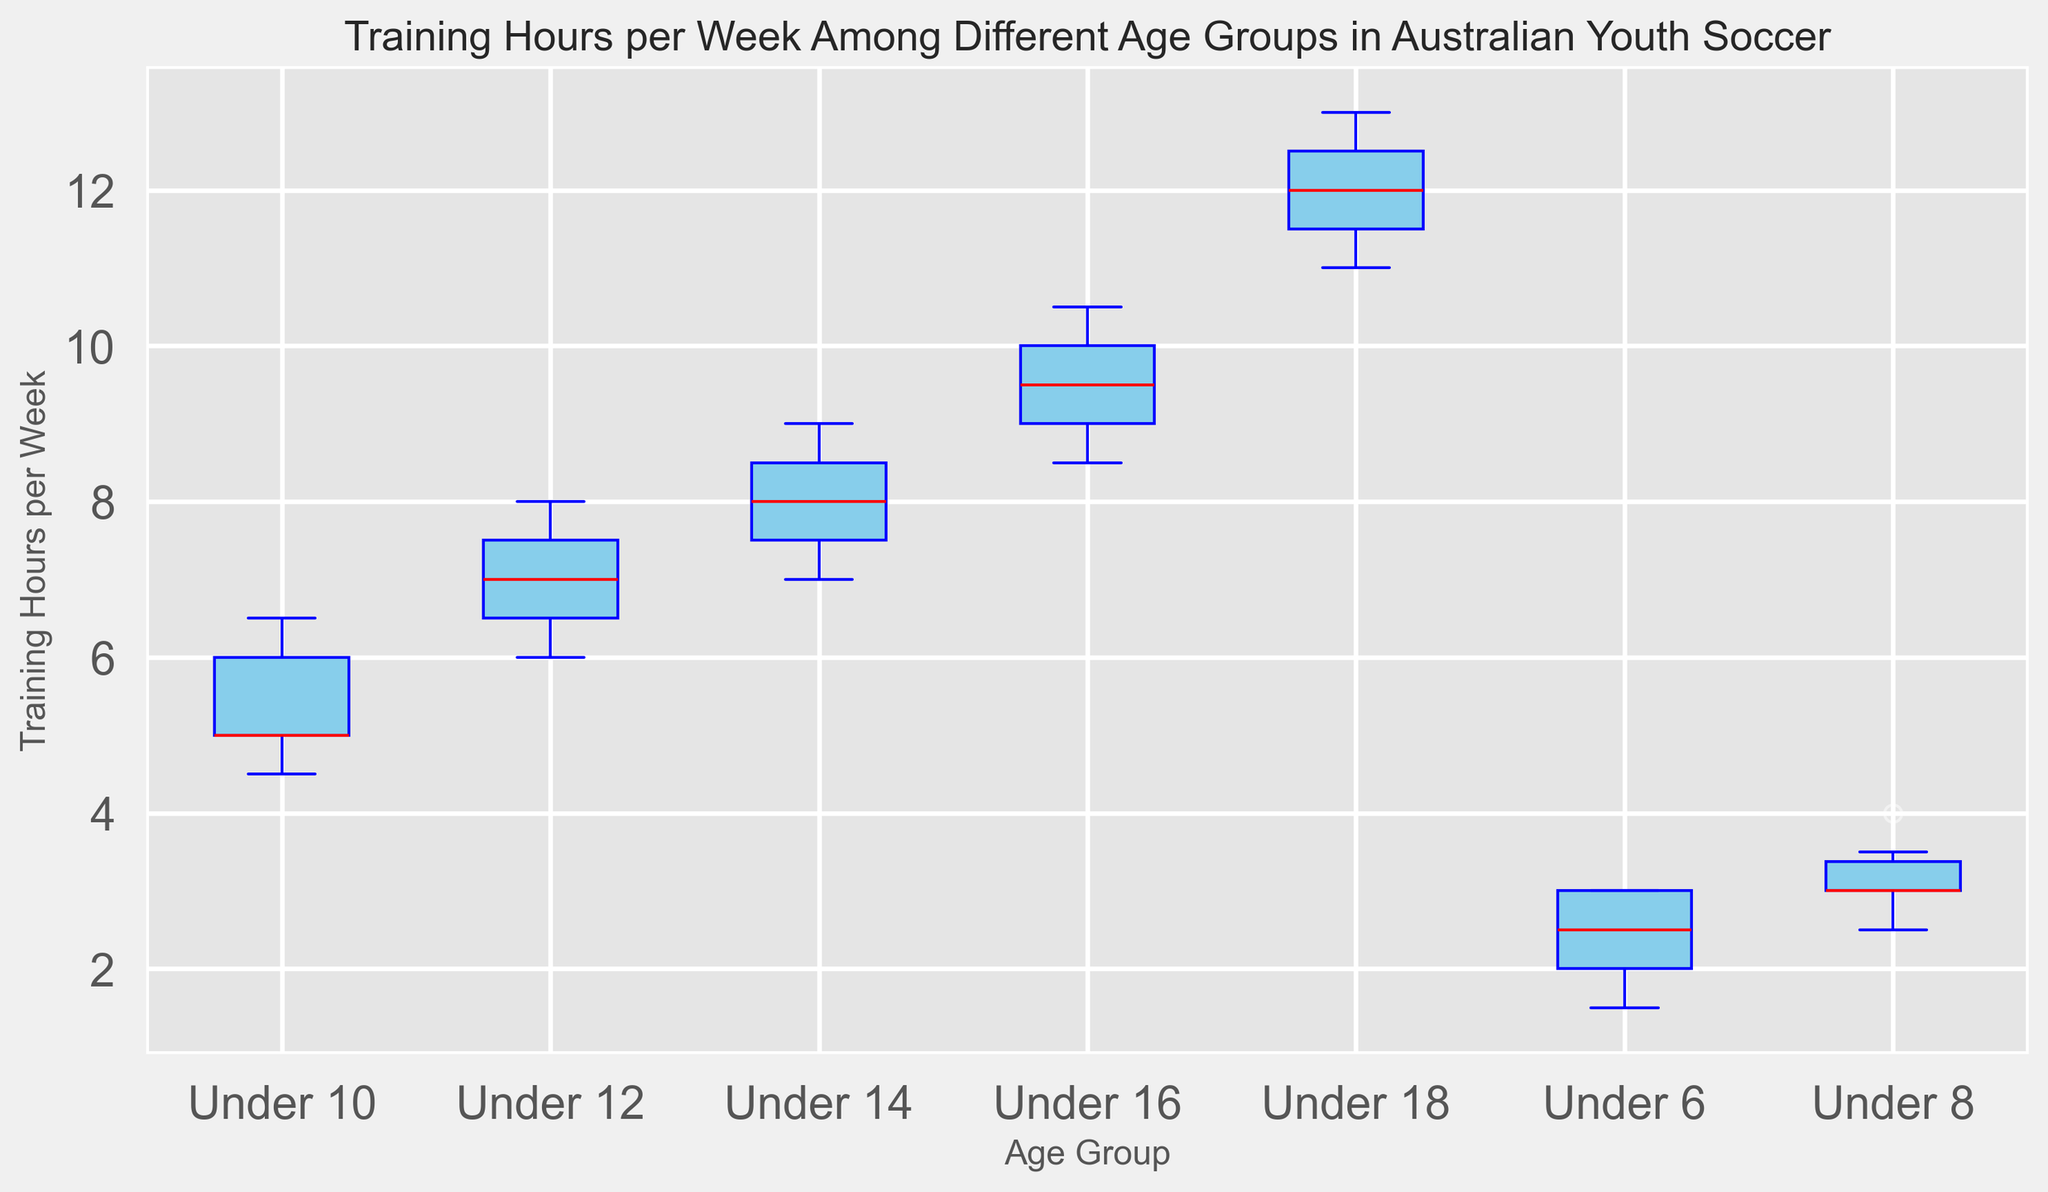Which age group has the highest median training hours per week? To determine this, look at the median red line inside each box plot. The Under 18 age group has the highest height of the red line, indicating the highest median.
Answer: Under 18 How does the median training hours per week change as the age group increases from Under 6 to Under 18? Observe the increasing trend of the median red line from Under 6 to Under 18. The medians progressively rise as the age groups get older: Under 6 has the lowest, and Under 18 has the highest median.
Answer: Increases What is the approximate range of training hours per week for the Under 10 age group? The range is the difference between the top and bottom whiskers. For the Under 10 age group, the top whisker is at about 6.5, and the bottom whisker is at about 4.5. So, 6.5 - 4.5 = 2.
Answer: 2 Which age group has the most variability in training hours per week? Variability can be indicated by the interquartile range (IQR), represented by the height of the box. The Under 18 age group has the highest boxes or spread, indicating more variability.
Answer: Under 18 Compare the median training hours per week of the Under 12 and Under 16 age groups. Which one is higher? Look at the median (red line) for both groups. Under 16 has a median training hours per week higher than Under 12.
Answer: Under 16 Which age group has outliers, and what are their values? Outliers are represented as individual points outside the whiskers. The Under 6 age group has an outlier indicated by a single point outside the whisker range. The value is around 1.5.
Answer: Under 6, 1.5 What is the interquartile range (IQR) for the Under 14 age group? The IQR is found by subtracting the lower quartile (bottom of the box) from the upper quartile (top of the box). For the Under 14 age group, this is approximately 8.5 - 7.5 = 1.
Answer: 1 